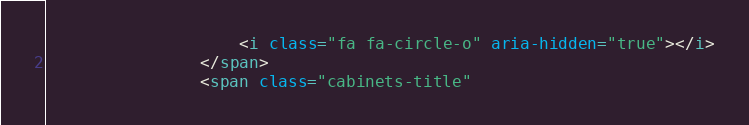Convert code to text. <code><loc_0><loc_0><loc_500><loc_500><_HTML_>            		<i class="fa fa-circle-o" aria-hidden="true"></i>
            	</span>
            	<span class="cabinets-title" </code> 